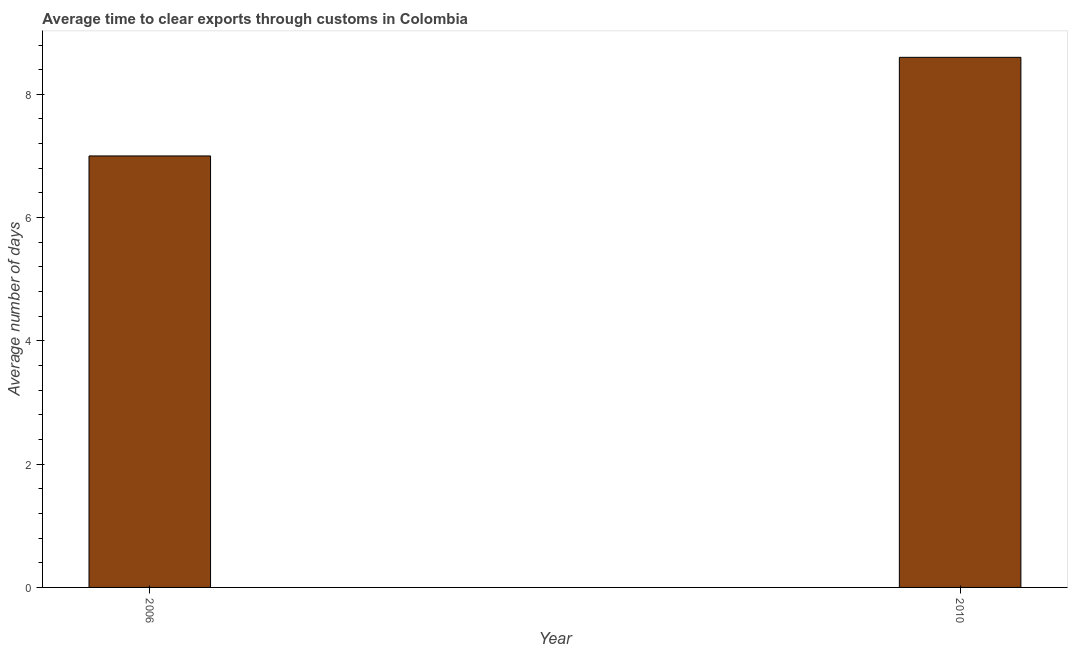Does the graph contain any zero values?
Offer a very short reply. No. Does the graph contain grids?
Provide a succinct answer. No. What is the title of the graph?
Give a very brief answer. Average time to clear exports through customs in Colombia. What is the label or title of the Y-axis?
Make the answer very short. Average number of days. What is the time to clear exports through customs in 2006?
Keep it short and to the point. 7. What is the sum of the time to clear exports through customs?
Keep it short and to the point. 15.6. What is the difference between the time to clear exports through customs in 2006 and 2010?
Your answer should be very brief. -1.6. What is the median time to clear exports through customs?
Ensure brevity in your answer.  7.8. Do a majority of the years between 2006 and 2010 (inclusive) have time to clear exports through customs greater than 1.2 days?
Offer a very short reply. Yes. What is the ratio of the time to clear exports through customs in 2006 to that in 2010?
Make the answer very short. 0.81. Is the time to clear exports through customs in 2006 less than that in 2010?
Offer a terse response. Yes. Are all the bars in the graph horizontal?
Offer a terse response. No. What is the difference between two consecutive major ticks on the Y-axis?
Provide a succinct answer. 2. Are the values on the major ticks of Y-axis written in scientific E-notation?
Your response must be concise. No. What is the ratio of the Average number of days in 2006 to that in 2010?
Provide a short and direct response. 0.81. 